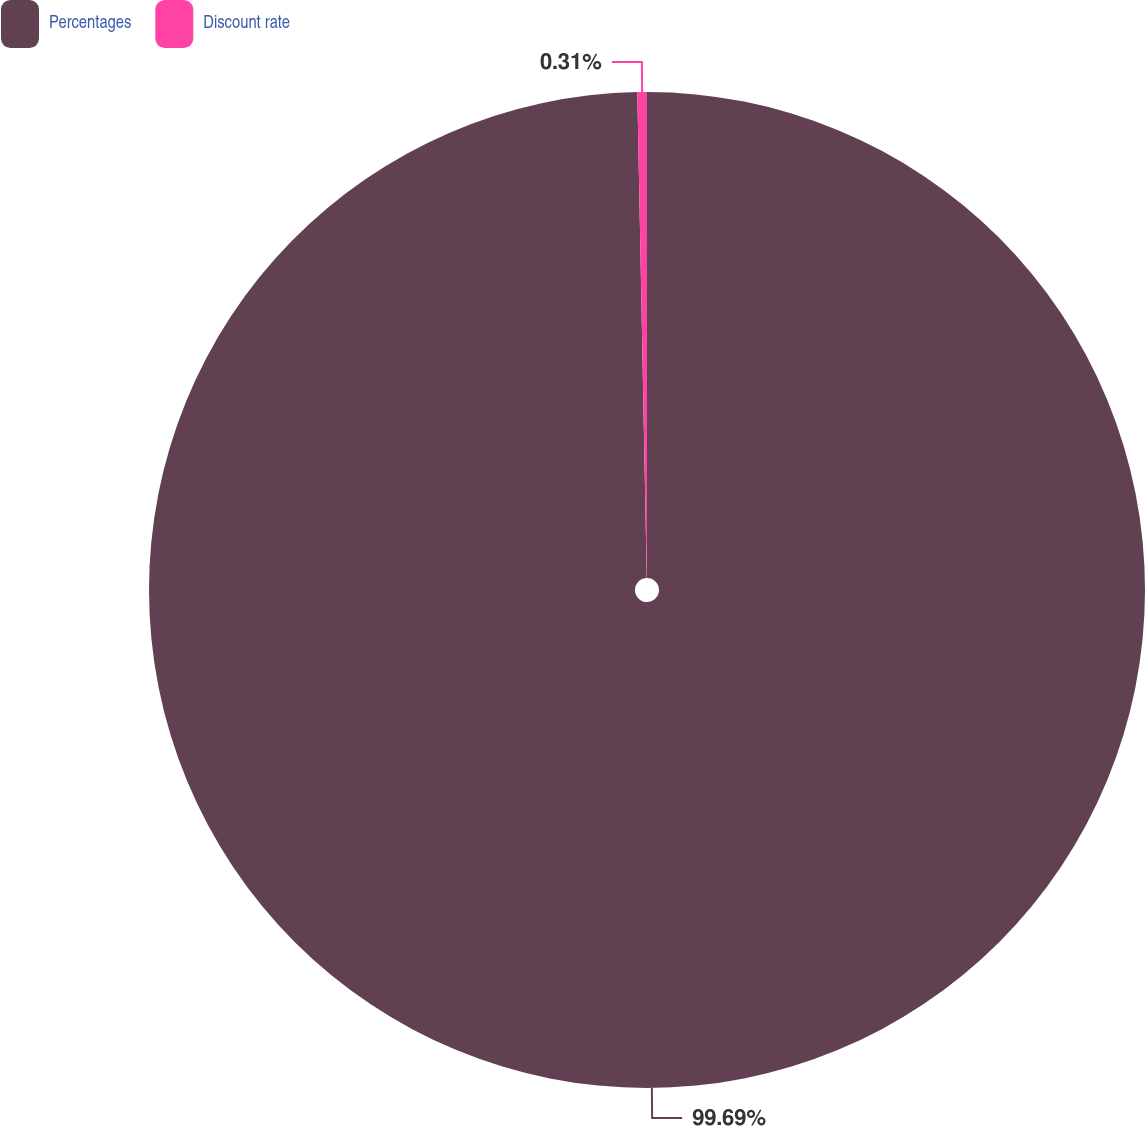Convert chart. <chart><loc_0><loc_0><loc_500><loc_500><pie_chart><fcel>Percentages<fcel>Discount rate<nl><fcel>99.69%<fcel>0.31%<nl></chart> 